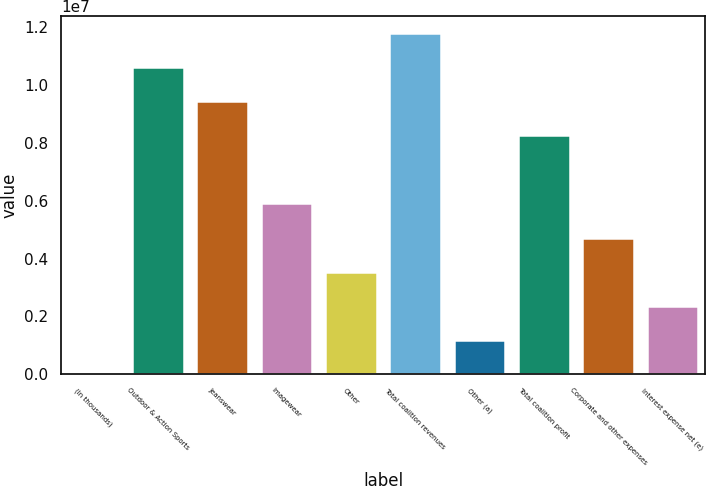Convert chart. <chart><loc_0><loc_0><loc_500><loc_500><bar_chart><fcel>(In thousands)<fcel>Outdoor & Action Sports<fcel>Jeanswear<fcel>Imagewear<fcel>Other<fcel>Total coalition revenues<fcel>Other (a)<fcel>Total coalition profit<fcel>Corporate and other expenses<fcel>Interest expense net (e)<nl><fcel>2017<fcel>1.06303e+07<fcel>9.44934e+06<fcel>5.9066e+06<fcel>3.54476e+06<fcel>1.18112e+07<fcel>1.18293e+06<fcel>8.26843e+06<fcel>4.72568e+06<fcel>2.36385e+06<nl></chart> 